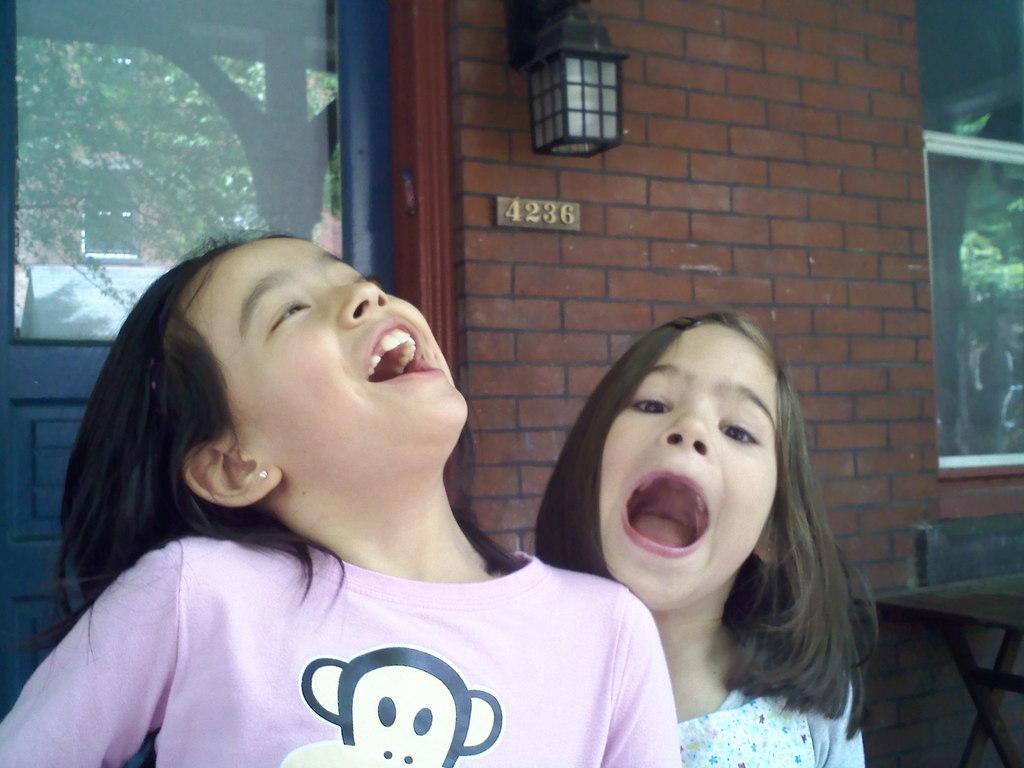In one or two sentences, can you explain what this image depicts? There are two girls at the bottom of this image and there is a wall in the background. There is a glass door on the left side of this image and we can see trees through it. There is a poster on the right side of this image. 